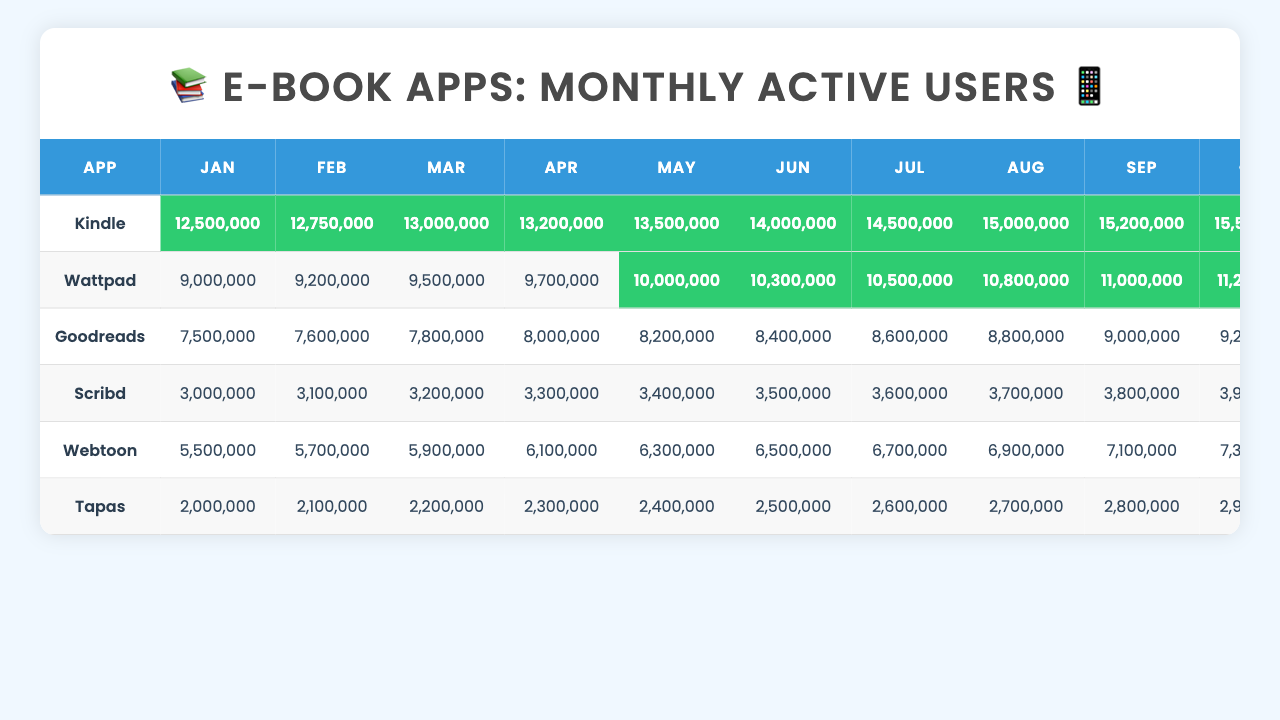What was the month with the highest active users for Kindle? Looking at the table, the highest number of active users for Kindle occurred in December, where the count reached 16,000,000.
Answer: December Which app showed consistent growth month-to-month? By examining the user counts month by month, it’s clear that all apps showed growth; however, Kindle had the most consistent upward trend throughout the entire year, starting from 12,500,000 in January and reaching 16,000,000 in December.
Answer: Kindle Did Wattpad surpass 11 million users in any month? Yes, Wattpad exceeded 11 million users for the first time in October, where it reached 11,200,000 users.
Answer: Yes What is the average number of active users for Goodreads over the year? To find the average, sum all user counts (7,500,000 + 7,600,000 + 7,800,000 + ... + 9,600,000 = 94,000,000) and then divide by 12 (the number of months), resulting in an average of approximately 7,833,333.
Answer: 7,833,333 In which month did Scribd see the lowest user count? Checking the table, Scribd had its lowest active user count in January, with 3,000,000 users.
Answer: January What is the total number of users for Webtoon over the year? By adding the user counts for each month (5,500,000 + 5,700,000 + 5,900,000 + ... + 7,700,000 = 76,300,000), we find that the total user count for Webtoon is 76,300,000.
Answer: 76,300,000 Which app had the fewest users in June? In June, Tapas had the fewest users at 2,500,000 compared to the other apps present in the table.
Answer: Tapas How much did the number of users for Kindle increase from January to December? The increase can be calculated as 16,000,000 (December) - 12,500,000 (January) = 3,500,000, indicating a growth of 3,500,000 users from the beginning to the end of the year.
Answer: 3,500,000 Is Scribd the least used app at the end of the year? Yes, by the end of December, Scribd had 4,100,000 active users, which is lower than all other apps listed in the table.
Answer: Yes How many more users did Wattpad have than Goodreads in November? In November, Wattpad had 11,400,000 users while Goodreads had 9,400,000. The difference is 11,400,000 - 9,400,000 = 2,000,000, indicating that Wattpad had 2,000,000 more users than Goodreads.
Answer: 2,000,000 Which app consistently had over 10 million users every month from June to December? Looking through the data, both Kindle and Wattpad consistently had over 10 million users from June to December.
Answer: Kindle and Wattpad 